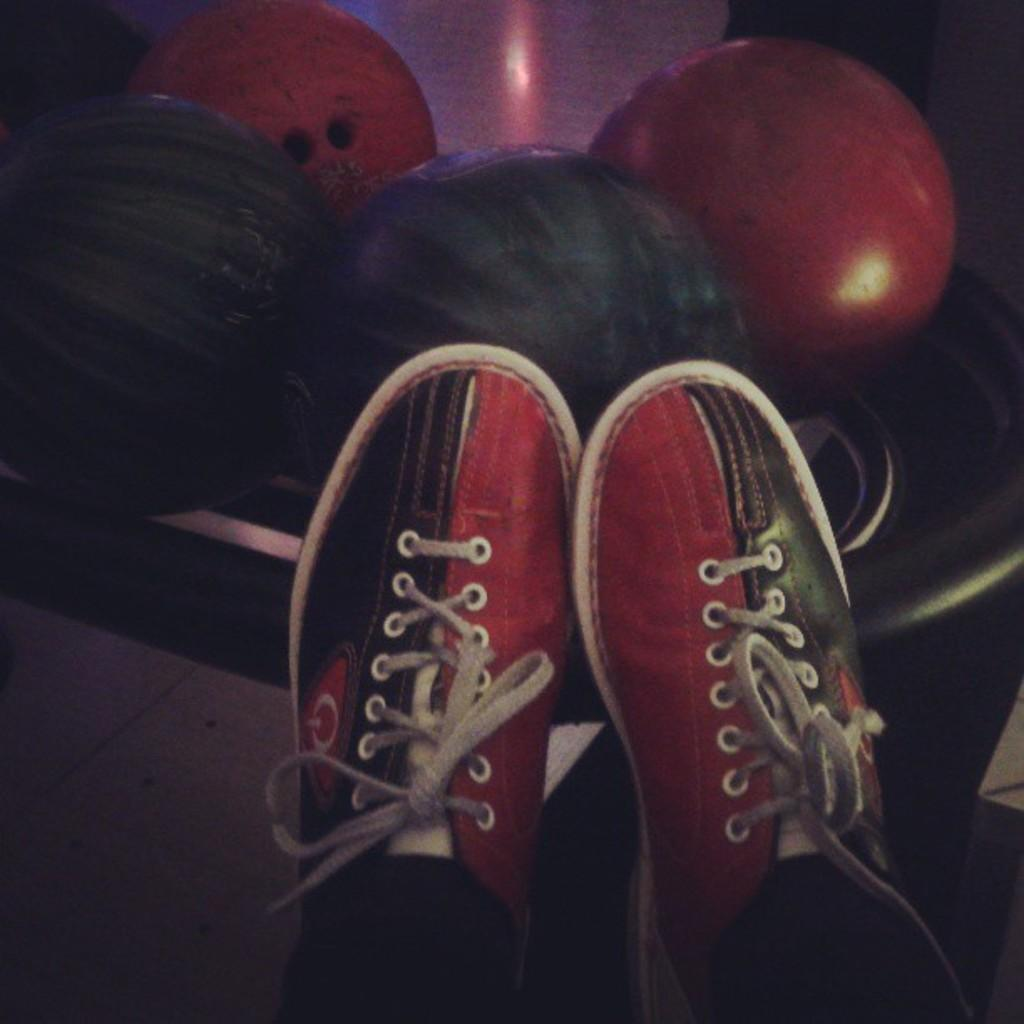What type of footwear is visible in the image? There is a pair of shoes in the image. What else can be seen on the floor behind the shoes? There are balls on the floor behind the shoes. How do the cows feel about the effect of the shoes on the grass in the image? There are no cows present in the image, so it is not possible to determine how they might feel about the effect of the shoes on the grass. 